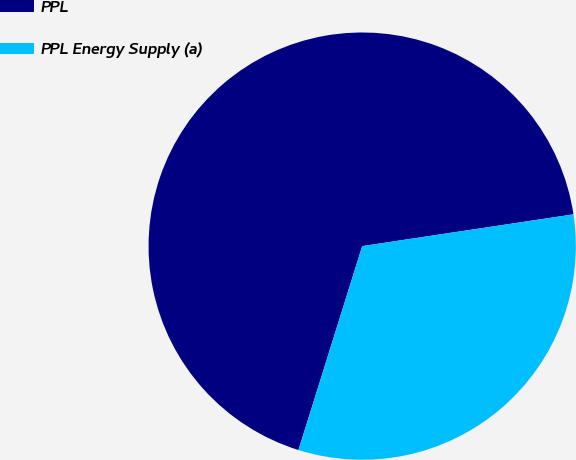Convert chart to OTSL. <chart><loc_0><loc_0><loc_500><loc_500><pie_chart><fcel>PPL<fcel>PPL Energy Supply (a)<nl><fcel>67.8%<fcel>32.2%<nl></chart> 